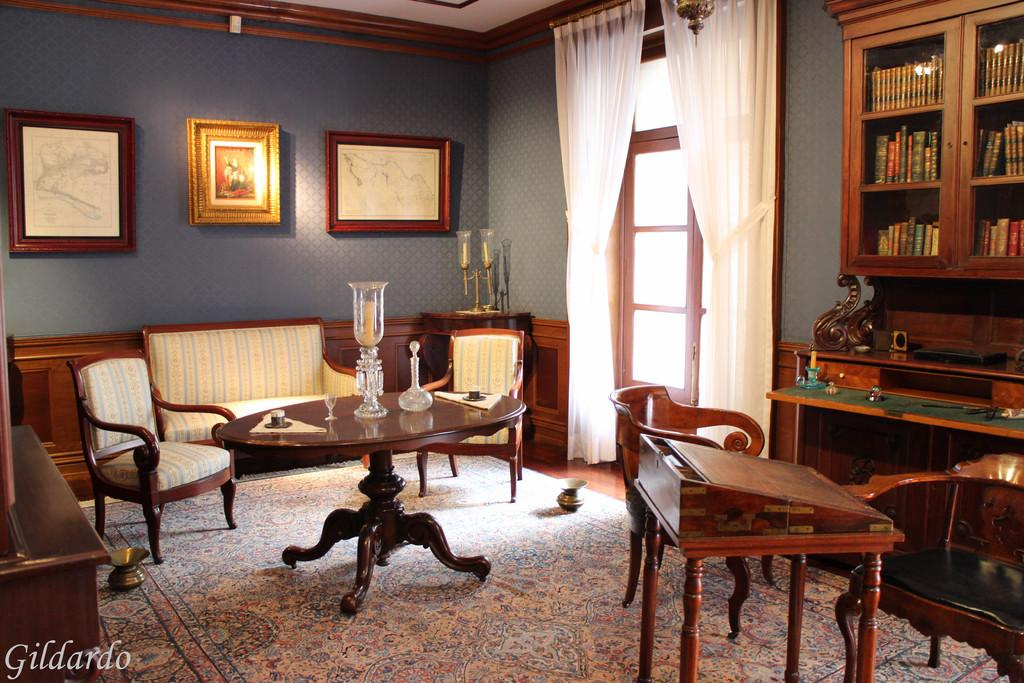What piece of furniture is in the center of the image? There is a table in the image. What can be seen in front of the table? There are chairs in front of the table. What architectural feature is present in the image? There is a door in the image. What type of storage furniture is in the image? There is a bookshelf in the image. What type of window treatment is present in the image? There are white curtains in the image. What type of underwear is hanging on the bookshelf in the image? There is no underwear present in the image; it only features a table, chairs, a door, a bookshelf, and white curtains. What crime is being committed in the image? There is no crime being committed in the image; it is a scene of a room with a table, chairs, a door, a bookshelf, and white curtains. 